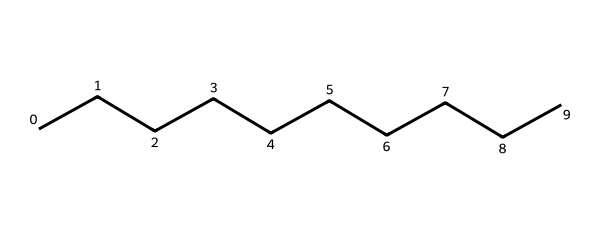How many carbon atoms are present in jet fuel represented by this SMILES? The SMILES "CCCCCCCCCC" indicates a straight chain of 'C's (carbon atoms). Since there are 10 'C's in this representation, it signifies that there are 10 carbon atoms.
Answer: 10 What type of hydrocarbon is represented by this SMILES? The structure "CCCCCCCCCC" shows a long alkane chain, specifically a linear alkane, as it consists only of carbon and hydrogen with single bonds. Alkane is defined as saturated hydrocarbons with the general formula CnH2n+2.
Answer: alkane What is the molecular formula for the hydrocarbon indicated by this SMILES? In the SMILES "CCCCCCCCCC" with 10 carbons, the number of hydrogen atoms can be calculated as 2(10) + 2 = 22. Therefore, the molecular formula is C10H22, which corresponds to the structure depicted.
Answer: C10H22 How many hydrogen atoms are linked to the carbon atoms in this jet fuel representation? To determine the number of hydrogen atoms in this structure, we apply the formula for alkanes. With 10 carbon atoms (C10), the number of hydrogen atoms is calculated as 2(10) + 2 = 22.
Answer: 22 What is the melting point range for hydrocarbons like the one represented by this SMILES? Kerosene, represented by this long straight-chain hydrocarbon, typically has a melting point around -50 to -20 degrees Celsius due to the influence of the number of carbon atoms, which create a range of phase states.
Answer: -50 to -20 degrees Celsius 